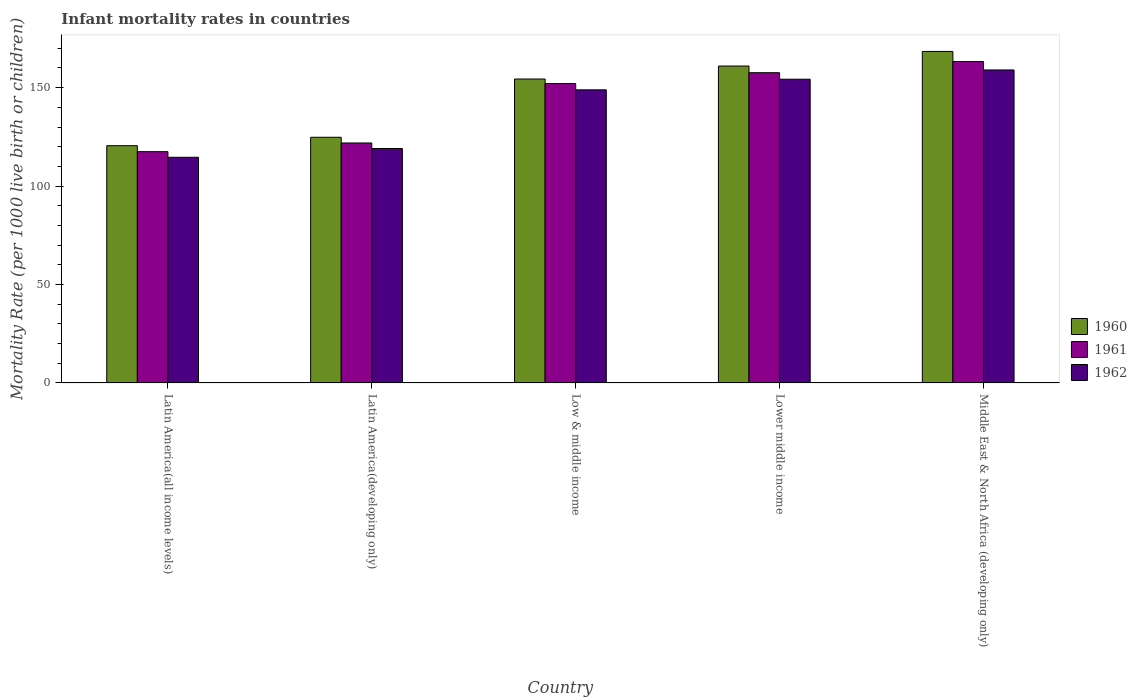How many groups of bars are there?
Offer a very short reply. 5. Are the number of bars per tick equal to the number of legend labels?
Give a very brief answer. Yes. Are the number of bars on each tick of the X-axis equal?
Your response must be concise. Yes. What is the label of the 5th group of bars from the left?
Your answer should be very brief. Middle East & North Africa (developing only). In how many cases, is the number of bars for a given country not equal to the number of legend labels?
Provide a succinct answer. 0. What is the infant mortality rate in 1961 in Latin America(all income levels)?
Give a very brief answer. 117.5. Across all countries, what is the maximum infant mortality rate in 1961?
Keep it short and to the point. 163.3. Across all countries, what is the minimum infant mortality rate in 1960?
Your answer should be very brief. 120.53. In which country was the infant mortality rate in 1960 maximum?
Ensure brevity in your answer.  Middle East & North Africa (developing only). In which country was the infant mortality rate in 1960 minimum?
Offer a terse response. Latin America(all income levels). What is the total infant mortality rate in 1961 in the graph?
Offer a terse response. 712.4. What is the difference between the infant mortality rate in 1961 in Latin America(all income levels) and that in Latin America(developing only)?
Offer a very short reply. -4.4. What is the difference between the infant mortality rate in 1962 in Low & middle income and the infant mortality rate in 1960 in Middle East & North Africa (developing only)?
Provide a succinct answer. -19.5. What is the average infant mortality rate in 1962 per country?
Your response must be concise. 139.19. What is the difference between the infant mortality rate of/in 1961 and infant mortality rate of/in 1960 in Low & middle income?
Provide a short and direct response. -2.3. In how many countries, is the infant mortality rate in 1960 greater than 20?
Offer a terse response. 5. What is the ratio of the infant mortality rate in 1962 in Latin America(all income levels) to that in Lower middle income?
Keep it short and to the point. 0.74. What is the difference between the highest and the second highest infant mortality rate in 1961?
Your answer should be very brief. -11.2. What is the difference between the highest and the lowest infant mortality rate in 1960?
Ensure brevity in your answer.  47.87. In how many countries, is the infant mortality rate in 1962 greater than the average infant mortality rate in 1962 taken over all countries?
Make the answer very short. 3. Is it the case that in every country, the sum of the infant mortality rate in 1961 and infant mortality rate in 1960 is greater than the infant mortality rate in 1962?
Make the answer very short. Yes. What is the difference between two consecutive major ticks on the Y-axis?
Make the answer very short. 50. Are the values on the major ticks of Y-axis written in scientific E-notation?
Make the answer very short. No. Does the graph contain any zero values?
Offer a terse response. No. Does the graph contain grids?
Provide a succinct answer. No. Where does the legend appear in the graph?
Give a very brief answer. Center right. How many legend labels are there?
Make the answer very short. 3. How are the legend labels stacked?
Offer a terse response. Vertical. What is the title of the graph?
Provide a succinct answer. Infant mortality rates in countries. What is the label or title of the Y-axis?
Provide a succinct answer. Mortality Rate (per 1000 live birth or children). What is the Mortality Rate (per 1000 live birth or children) in 1960 in Latin America(all income levels)?
Make the answer very short. 120.53. What is the Mortality Rate (per 1000 live birth or children) of 1961 in Latin America(all income levels)?
Offer a terse response. 117.5. What is the Mortality Rate (per 1000 live birth or children) of 1962 in Latin America(all income levels)?
Give a very brief answer. 114.64. What is the Mortality Rate (per 1000 live birth or children) in 1960 in Latin America(developing only)?
Offer a terse response. 124.8. What is the Mortality Rate (per 1000 live birth or children) in 1961 in Latin America(developing only)?
Your answer should be very brief. 121.9. What is the Mortality Rate (per 1000 live birth or children) in 1962 in Latin America(developing only)?
Your answer should be compact. 119.1. What is the Mortality Rate (per 1000 live birth or children) of 1960 in Low & middle income?
Your answer should be compact. 154.4. What is the Mortality Rate (per 1000 live birth or children) of 1961 in Low & middle income?
Ensure brevity in your answer.  152.1. What is the Mortality Rate (per 1000 live birth or children) in 1962 in Low & middle income?
Give a very brief answer. 148.9. What is the Mortality Rate (per 1000 live birth or children) in 1960 in Lower middle income?
Offer a terse response. 161. What is the Mortality Rate (per 1000 live birth or children) of 1961 in Lower middle income?
Your answer should be very brief. 157.6. What is the Mortality Rate (per 1000 live birth or children) in 1962 in Lower middle income?
Provide a short and direct response. 154.3. What is the Mortality Rate (per 1000 live birth or children) in 1960 in Middle East & North Africa (developing only)?
Offer a terse response. 168.4. What is the Mortality Rate (per 1000 live birth or children) of 1961 in Middle East & North Africa (developing only)?
Your response must be concise. 163.3. What is the Mortality Rate (per 1000 live birth or children) in 1962 in Middle East & North Africa (developing only)?
Keep it short and to the point. 159. Across all countries, what is the maximum Mortality Rate (per 1000 live birth or children) of 1960?
Give a very brief answer. 168.4. Across all countries, what is the maximum Mortality Rate (per 1000 live birth or children) of 1961?
Offer a very short reply. 163.3. Across all countries, what is the maximum Mortality Rate (per 1000 live birth or children) of 1962?
Provide a succinct answer. 159. Across all countries, what is the minimum Mortality Rate (per 1000 live birth or children) of 1960?
Offer a very short reply. 120.53. Across all countries, what is the minimum Mortality Rate (per 1000 live birth or children) of 1961?
Offer a very short reply. 117.5. Across all countries, what is the minimum Mortality Rate (per 1000 live birth or children) in 1962?
Provide a short and direct response. 114.64. What is the total Mortality Rate (per 1000 live birth or children) of 1960 in the graph?
Your answer should be very brief. 729.13. What is the total Mortality Rate (per 1000 live birth or children) in 1961 in the graph?
Make the answer very short. 712.4. What is the total Mortality Rate (per 1000 live birth or children) in 1962 in the graph?
Ensure brevity in your answer.  695.94. What is the difference between the Mortality Rate (per 1000 live birth or children) in 1960 in Latin America(all income levels) and that in Latin America(developing only)?
Your answer should be very brief. -4.27. What is the difference between the Mortality Rate (per 1000 live birth or children) of 1961 in Latin America(all income levels) and that in Latin America(developing only)?
Give a very brief answer. -4.4. What is the difference between the Mortality Rate (per 1000 live birth or children) in 1962 in Latin America(all income levels) and that in Latin America(developing only)?
Give a very brief answer. -4.46. What is the difference between the Mortality Rate (per 1000 live birth or children) in 1960 in Latin America(all income levels) and that in Low & middle income?
Your answer should be compact. -33.87. What is the difference between the Mortality Rate (per 1000 live birth or children) in 1961 in Latin America(all income levels) and that in Low & middle income?
Offer a terse response. -34.6. What is the difference between the Mortality Rate (per 1000 live birth or children) in 1962 in Latin America(all income levels) and that in Low & middle income?
Give a very brief answer. -34.26. What is the difference between the Mortality Rate (per 1000 live birth or children) of 1960 in Latin America(all income levels) and that in Lower middle income?
Your answer should be very brief. -40.47. What is the difference between the Mortality Rate (per 1000 live birth or children) of 1961 in Latin America(all income levels) and that in Lower middle income?
Offer a very short reply. -40.1. What is the difference between the Mortality Rate (per 1000 live birth or children) of 1962 in Latin America(all income levels) and that in Lower middle income?
Provide a succinct answer. -39.66. What is the difference between the Mortality Rate (per 1000 live birth or children) in 1960 in Latin America(all income levels) and that in Middle East & North Africa (developing only)?
Provide a short and direct response. -47.87. What is the difference between the Mortality Rate (per 1000 live birth or children) of 1961 in Latin America(all income levels) and that in Middle East & North Africa (developing only)?
Offer a terse response. -45.8. What is the difference between the Mortality Rate (per 1000 live birth or children) of 1962 in Latin America(all income levels) and that in Middle East & North Africa (developing only)?
Your answer should be compact. -44.36. What is the difference between the Mortality Rate (per 1000 live birth or children) of 1960 in Latin America(developing only) and that in Low & middle income?
Provide a short and direct response. -29.6. What is the difference between the Mortality Rate (per 1000 live birth or children) in 1961 in Latin America(developing only) and that in Low & middle income?
Ensure brevity in your answer.  -30.2. What is the difference between the Mortality Rate (per 1000 live birth or children) of 1962 in Latin America(developing only) and that in Low & middle income?
Your answer should be compact. -29.8. What is the difference between the Mortality Rate (per 1000 live birth or children) of 1960 in Latin America(developing only) and that in Lower middle income?
Your answer should be compact. -36.2. What is the difference between the Mortality Rate (per 1000 live birth or children) of 1961 in Latin America(developing only) and that in Lower middle income?
Your answer should be compact. -35.7. What is the difference between the Mortality Rate (per 1000 live birth or children) of 1962 in Latin America(developing only) and that in Lower middle income?
Provide a short and direct response. -35.2. What is the difference between the Mortality Rate (per 1000 live birth or children) of 1960 in Latin America(developing only) and that in Middle East & North Africa (developing only)?
Your answer should be very brief. -43.6. What is the difference between the Mortality Rate (per 1000 live birth or children) of 1961 in Latin America(developing only) and that in Middle East & North Africa (developing only)?
Your answer should be compact. -41.4. What is the difference between the Mortality Rate (per 1000 live birth or children) of 1962 in Latin America(developing only) and that in Middle East & North Africa (developing only)?
Your answer should be compact. -39.9. What is the difference between the Mortality Rate (per 1000 live birth or children) in 1961 in Low & middle income and that in Lower middle income?
Keep it short and to the point. -5.5. What is the difference between the Mortality Rate (per 1000 live birth or children) of 1962 in Low & middle income and that in Lower middle income?
Make the answer very short. -5.4. What is the difference between the Mortality Rate (per 1000 live birth or children) in 1961 in Low & middle income and that in Middle East & North Africa (developing only)?
Your response must be concise. -11.2. What is the difference between the Mortality Rate (per 1000 live birth or children) in 1962 in Low & middle income and that in Middle East & North Africa (developing only)?
Make the answer very short. -10.1. What is the difference between the Mortality Rate (per 1000 live birth or children) in 1960 in Latin America(all income levels) and the Mortality Rate (per 1000 live birth or children) in 1961 in Latin America(developing only)?
Provide a short and direct response. -1.37. What is the difference between the Mortality Rate (per 1000 live birth or children) in 1960 in Latin America(all income levels) and the Mortality Rate (per 1000 live birth or children) in 1962 in Latin America(developing only)?
Provide a short and direct response. 1.43. What is the difference between the Mortality Rate (per 1000 live birth or children) in 1961 in Latin America(all income levels) and the Mortality Rate (per 1000 live birth or children) in 1962 in Latin America(developing only)?
Your answer should be compact. -1.6. What is the difference between the Mortality Rate (per 1000 live birth or children) of 1960 in Latin America(all income levels) and the Mortality Rate (per 1000 live birth or children) of 1961 in Low & middle income?
Make the answer very short. -31.57. What is the difference between the Mortality Rate (per 1000 live birth or children) of 1960 in Latin America(all income levels) and the Mortality Rate (per 1000 live birth or children) of 1962 in Low & middle income?
Offer a terse response. -28.37. What is the difference between the Mortality Rate (per 1000 live birth or children) in 1961 in Latin America(all income levels) and the Mortality Rate (per 1000 live birth or children) in 1962 in Low & middle income?
Provide a succinct answer. -31.4. What is the difference between the Mortality Rate (per 1000 live birth or children) of 1960 in Latin America(all income levels) and the Mortality Rate (per 1000 live birth or children) of 1961 in Lower middle income?
Offer a very short reply. -37.07. What is the difference between the Mortality Rate (per 1000 live birth or children) in 1960 in Latin America(all income levels) and the Mortality Rate (per 1000 live birth or children) in 1962 in Lower middle income?
Your answer should be very brief. -33.77. What is the difference between the Mortality Rate (per 1000 live birth or children) in 1961 in Latin America(all income levels) and the Mortality Rate (per 1000 live birth or children) in 1962 in Lower middle income?
Provide a short and direct response. -36.8. What is the difference between the Mortality Rate (per 1000 live birth or children) in 1960 in Latin America(all income levels) and the Mortality Rate (per 1000 live birth or children) in 1961 in Middle East & North Africa (developing only)?
Provide a short and direct response. -42.77. What is the difference between the Mortality Rate (per 1000 live birth or children) in 1960 in Latin America(all income levels) and the Mortality Rate (per 1000 live birth or children) in 1962 in Middle East & North Africa (developing only)?
Give a very brief answer. -38.47. What is the difference between the Mortality Rate (per 1000 live birth or children) of 1961 in Latin America(all income levels) and the Mortality Rate (per 1000 live birth or children) of 1962 in Middle East & North Africa (developing only)?
Ensure brevity in your answer.  -41.5. What is the difference between the Mortality Rate (per 1000 live birth or children) in 1960 in Latin America(developing only) and the Mortality Rate (per 1000 live birth or children) in 1961 in Low & middle income?
Offer a very short reply. -27.3. What is the difference between the Mortality Rate (per 1000 live birth or children) of 1960 in Latin America(developing only) and the Mortality Rate (per 1000 live birth or children) of 1962 in Low & middle income?
Your response must be concise. -24.1. What is the difference between the Mortality Rate (per 1000 live birth or children) of 1961 in Latin America(developing only) and the Mortality Rate (per 1000 live birth or children) of 1962 in Low & middle income?
Give a very brief answer. -27. What is the difference between the Mortality Rate (per 1000 live birth or children) in 1960 in Latin America(developing only) and the Mortality Rate (per 1000 live birth or children) in 1961 in Lower middle income?
Give a very brief answer. -32.8. What is the difference between the Mortality Rate (per 1000 live birth or children) in 1960 in Latin America(developing only) and the Mortality Rate (per 1000 live birth or children) in 1962 in Lower middle income?
Ensure brevity in your answer.  -29.5. What is the difference between the Mortality Rate (per 1000 live birth or children) of 1961 in Latin America(developing only) and the Mortality Rate (per 1000 live birth or children) of 1962 in Lower middle income?
Give a very brief answer. -32.4. What is the difference between the Mortality Rate (per 1000 live birth or children) in 1960 in Latin America(developing only) and the Mortality Rate (per 1000 live birth or children) in 1961 in Middle East & North Africa (developing only)?
Provide a succinct answer. -38.5. What is the difference between the Mortality Rate (per 1000 live birth or children) of 1960 in Latin America(developing only) and the Mortality Rate (per 1000 live birth or children) of 1962 in Middle East & North Africa (developing only)?
Ensure brevity in your answer.  -34.2. What is the difference between the Mortality Rate (per 1000 live birth or children) of 1961 in Latin America(developing only) and the Mortality Rate (per 1000 live birth or children) of 1962 in Middle East & North Africa (developing only)?
Keep it short and to the point. -37.1. What is the difference between the Mortality Rate (per 1000 live birth or children) of 1960 in Low & middle income and the Mortality Rate (per 1000 live birth or children) of 1961 in Lower middle income?
Provide a succinct answer. -3.2. What is the difference between the Mortality Rate (per 1000 live birth or children) in 1960 in Low & middle income and the Mortality Rate (per 1000 live birth or children) in 1962 in Middle East & North Africa (developing only)?
Offer a very short reply. -4.6. What is the difference between the Mortality Rate (per 1000 live birth or children) of 1961 in Low & middle income and the Mortality Rate (per 1000 live birth or children) of 1962 in Middle East & North Africa (developing only)?
Offer a terse response. -6.9. What is the difference between the Mortality Rate (per 1000 live birth or children) of 1960 in Lower middle income and the Mortality Rate (per 1000 live birth or children) of 1961 in Middle East & North Africa (developing only)?
Give a very brief answer. -2.3. What is the difference between the Mortality Rate (per 1000 live birth or children) of 1961 in Lower middle income and the Mortality Rate (per 1000 live birth or children) of 1962 in Middle East & North Africa (developing only)?
Give a very brief answer. -1.4. What is the average Mortality Rate (per 1000 live birth or children) of 1960 per country?
Provide a succinct answer. 145.83. What is the average Mortality Rate (per 1000 live birth or children) of 1961 per country?
Your answer should be very brief. 142.48. What is the average Mortality Rate (per 1000 live birth or children) of 1962 per country?
Offer a very short reply. 139.19. What is the difference between the Mortality Rate (per 1000 live birth or children) of 1960 and Mortality Rate (per 1000 live birth or children) of 1961 in Latin America(all income levels)?
Offer a terse response. 3.03. What is the difference between the Mortality Rate (per 1000 live birth or children) of 1960 and Mortality Rate (per 1000 live birth or children) of 1962 in Latin America(all income levels)?
Your answer should be very brief. 5.9. What is the difference between the Mortality Rate (per 1000 live birth or children) in 1961 and Mortality Rate (per 1000 live birth or children) in 1962 in Latin America(all income levels)?
Make the answer very short. 2.87. What is the difference between the Mortality Rate (per 1000 live birth or children) of 1960 and Mortality Rate (per 1000 live birth or children) of 1962 in Latin America(developing only)?
Offer a terse response. 5.7. What is the difference between the Mortality Rate (per 1000 live birth or children) in 1961 and Mortality Rate (per 1000 live birth or children) in 1962 in Latin America(developing only)?
Your answer should be very brief. 2.8. What is the difference between the Mortality Rate (per 1000 live birth or children) in 1960 and Mortality Rate (per 1000 live birth or children) in 1962 in Low & middle income?
Keep it short and to the point. 5.5. What is the difference between the Mortality Rate (per 1000 live birth or children) in 1961 and Mortality Rate (per 1000 live birth or children) in 1962 in Low & middle income?
Keep it short and to the point. 3.2. What is the difference between the Mortality Rate (per 1000 live birth or children) of 1960 and Mortality Rate (per 1000 live birth or children) of 1961 in Lower middle income?
Offer a terse response. 3.4. What is the difference between the Mortality Rate (per 1000 live birth or children) of 1960 and Mortality Rate (per 1000 live birth or children) of 1962 in Lower middle income?
Offer a terse response. 6.7. What is the difference between the Mortality Rate (per 1000 live birth or children) of 1960 and Mortality Rate (per 1000 live birth or children) of 1962 in Middle East & North Africa (developing only)?
Give a very brief answer. 9.4. What is the difference between the Mortality Rate (per 1000 live birth or children) of 1961 and Mortality Rate (per 1000 live birth or children) of 1962 in Middle East & North Africa (developing only)?
Ensure brevity in your answer.  4.3. What is the ratio of the Mortality Rate (per 1000 live birth or children) of 1960 in Latin America(all income levels) to that in Latin America(developing only)?
Offer a very short reply. 0.97. What is the ratio of the Mortality Rate (per 1000 live birth or children) in 1961 in Latin America(all income levels) to that in Latin America(developing only)?
Provide a succinct answer. 0.96. What is the ratio of the Mortality Rate (per 1000 live birth or children) of 1962 in Latin America(all income levels) to that in Latin America(developing only)?
Your answer should be compact. 0.96. What is the ratio of the Mortality Rate (per 1000 live birth or children) of 1960 in Latin America(all income levels) to that in Low & middle income?
Offer a terse response. 0.78. What is the ratio of the Mortality Rate (per 1000 live birth or children) in 1961 in Latin America(all income levels) to that in Low & middle income?
Your answer should be compact. 0.77. What is the ratio of the Mortality Rate (per 1000 live birth or children) of 1962 in Latin America(all income levels) to that in Low & middle income?
Your answer should be compact. 0.77. What is the ratio of the Mortality Rate (per 1000 live birth or children) in 1960 in Latin America(all income levels) to that in Lower middle income?
Provide a succinct answer. 0.75. What is the ratio of the Mortality Rate (per 1000 live birth or children) in 1961 in Latin America(all income levels) to that in Lower middle income?
Your answer should be very brief. 0.75. What is the ratio of the Mortality Rate (per 1000 live birth or children) of 1962 in Latin America(all income levels) to that in Lower middle income?
Provide a short and direct response. 0.74. What is the ratio of the Mortality Rate (per 1000 live birth or children) in 1960 in Latin America(all income levels) to that in Middle East & North Africa (developing only)?
Provide a short and direct response. 0.72. What is the ratio of the Mortality Rate (per 1000 live birth or children) in 1961 in Latin America(all income levels) to that in Middle East & North Africa (developing only)?
Your response must be concise. 0.72. What is the ratio of the Mortality Rate (per 1000 live birth or children) in 1962 in Latin America(all income levels) to that in Middle East & North Africa (developing only)?
Offer a very short reply. 0.72. What is the ratio of the Mortality Rate (per 1000 live birth or children) in 1960 in Latin America(developing only) to that in Low & middle income?
Make the answer very short. 0.81. What is the ratio of the Mortality Rate (per 1000 live birth or children) of 1961 in Latin America(developing only) to that in Low & middle income?
Provide a succinct answer. 0.8. What is the ratio of the Mortality Rate (per 1000 live birth or children) in 1962 in Latin America(developing only) to that in Low & middle income?
Your answer should be compact. 0.8. What is the ratio of the Mortality Rate (per 1000 live birth or children) in 1960 in Latin America(developing only) to that in Lower middle income?
Your answer should be compact. 0.78. What is the ratio of the Mortality Rate (per 1000 live birth or children) of 1961 in Latin America(developing only) to that in Lower middle income?
Give a very brief answer. 0.77. What is the ratio of the Mortality Rate (per 1000 live birth or children) in 1962 in Latin America(developing only) to that in Lower middle income?
Offer a very short reply. 0.77. What is the ratio of the Mortality Rate (per 1000 live birth or children) of 1960 in Latin America(developing only) to that in Middle East & North Africa (developing only)?
Make the answer very short. 0.74. What is the ratio of the Mortality Rate (per 1000 live birth or children) of 1961 in Latin America(developing only) to that in Middle East & North Africa (developing only)?
Offer a terse response. 0.75. What is the ratio of the Mortality Rate (per 1000 live birth or children) in 1962 in Latin America(developing only) to that in Middle East & North Africa (developing only)?
Your answer should be compact. 0.75. What is the ratio of the Mortality Rate (per 1000 live birth or children) in 1961 in Low & middle income to that in Lower middle income?
Your response must be concise. 0.97. What is the ratio of the Mortality Rate (per 1000 live birth or children) of 1962 in Low & middle income to that in Lower middle income?
Offer a terse response. 0.96. What is the ratio of the Mortality Rate (per 1000 live birth or children) in 1960 in Low & middle income to that in Middle East & North Africa (developing only)?
Your answer should be compact. 0.92. What is the ratio of the Mortality Rate (per 1000 live birth or children) in 1961 in Low & middle income to that in Middle East & North Africa (developing only)?
Offer a very short reply. 0.93. What is the ratio of the Mortality Rate (per 1000 live birth or children) in 1962 in Low & middle income to that in Middle East & North Africa (developing only)?
Offer a terse response. 0.94. What is the ratio of the Mortality Rate (per 1000 live birth or children) of 1960 in Lower middle income to that in Middle East & North Africa (developing only)?
Offer a very short reply. 0.96. What is the ratio of the Mortality Rate (per 1000 live birth or children) of 1961 in Lower middle income to that in Middle East & North Africa (developing only)?
Provide a succinct answer. 0.97. What is the ratio of the Mortality Rate (per 1000 live birth or children) of 1962 in Lower middle income to that in Middle East & North Africa (developing only)?
Provide a short and direct response. 0.97. What is the difference between the highest and the lowest Mortality Rate (per 1000 live birth or children) of 1960?
Keep it short and to the point. 47.87. What is the difference between the highest and the lowest Mortality Rate (per 1000 live birth or children) of 1961?
Your answer should be compact. 45.8. What is the difference between the highest and the lowest Mortality Rate (per 1000 live birth or children) in 1962?
Keep it short and to the point. 44.36. 